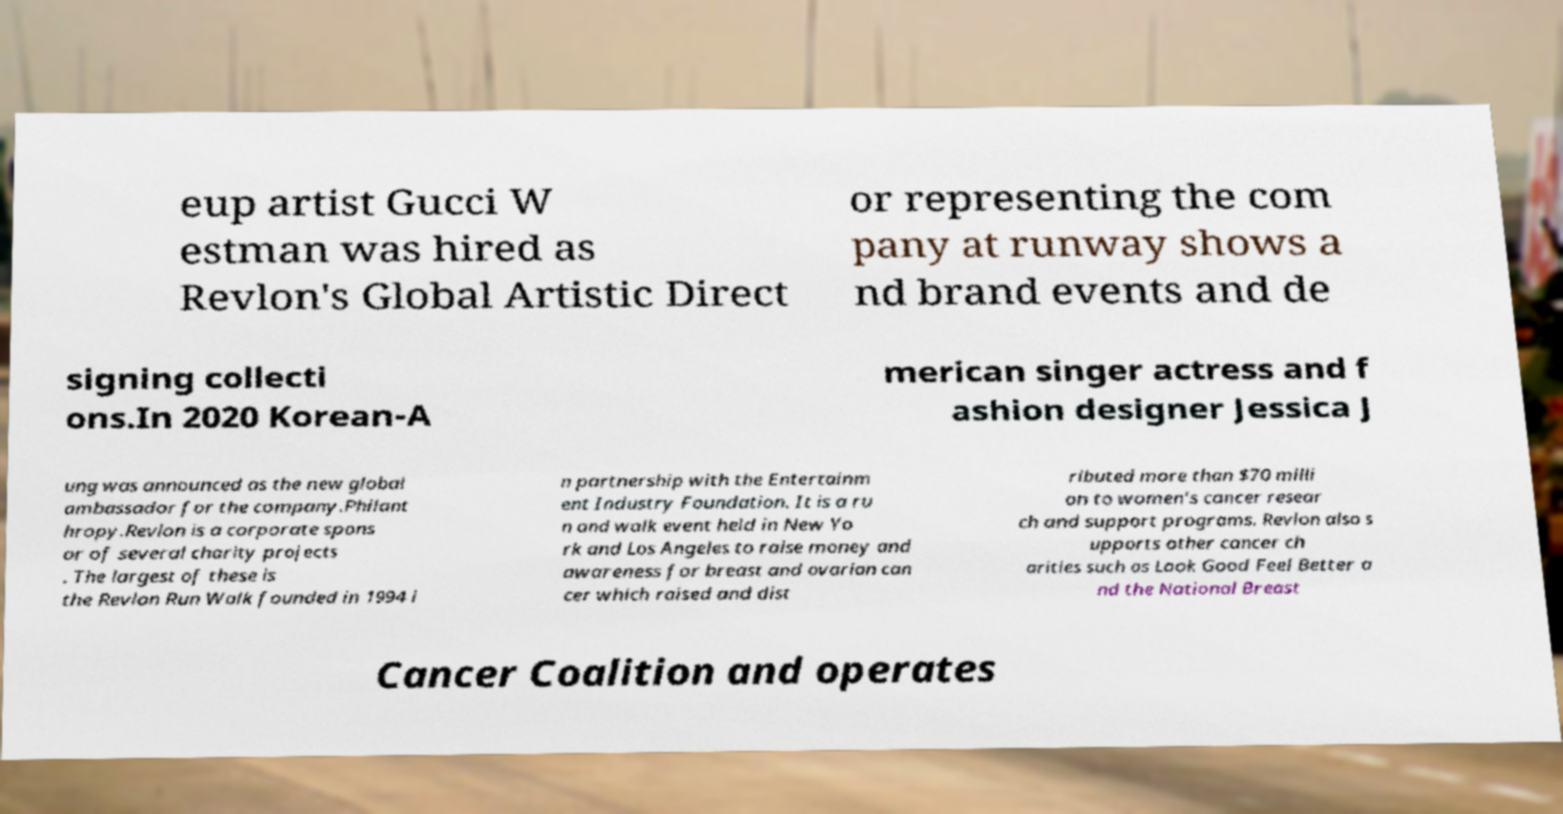For documentation purposes, I need the text within this image transcribed. Could you provide that? eup artist Gucci W estman was hired as Revlon's Global Artistic Direct or representing the com pany at runway shows a nd brand events and de signing collecti ons.In 2020 Korean-A merican singer actress and f ashion designer Jessica J ung was announced as the new global ambassador for the company.Philant hropy.Revlon is a corporate spons or of several charity projects . The largest of these is the Revlon Run Walk founded in 1994 i n partnership with the Entertainm ent Industry Foundation. It is a ru n and walk event held in New Yo rk and Los Angeles to raise money and awareness for breast and ovarian can cer which raised and dist ributed more than $70 milli on to women’s cancer resear ch and support programs. Revlon also s upports other cancer ch arities such as Look Good Feel Better a nd the National Breast Cancer Coalition and operates 